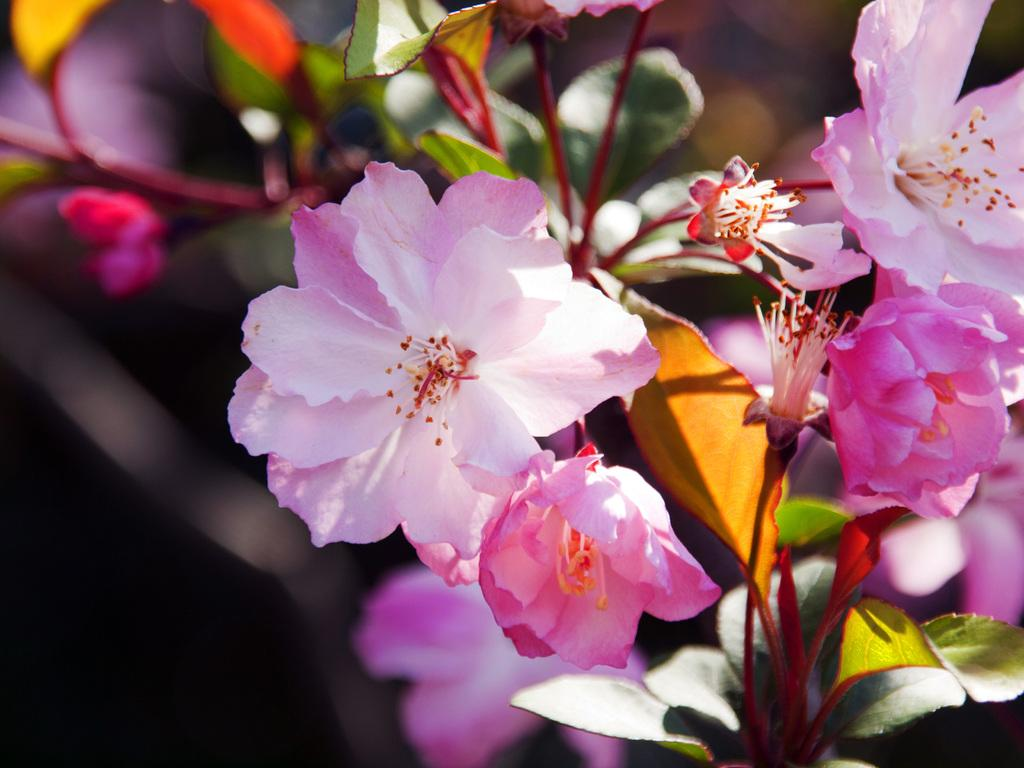What is the main subject of the image? The main subject of the image is a group of flowers. Can you describe any additional features of the flowers? There are leaves on the stems of the plant in the image. How many inventions can be seen in the image? There are no inventions present in the image; it features a group of flowers and leaves on the stems. What type of coast is visible in the image? There is no coast visible in the image; it features a group of flowers and leaves on the stems. 